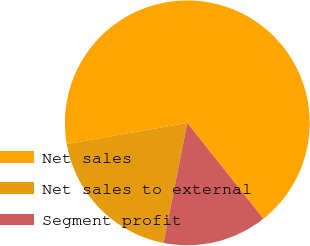<chart> <loc_0><loc_0><loc_500><loc_500><pie_chart><fcel>Net sales<fcel>Net sales to external<fcel>Segment profit<nl><fcel>67.08%<fcel>19.12%<fcel>13.79%<nl></chart> 